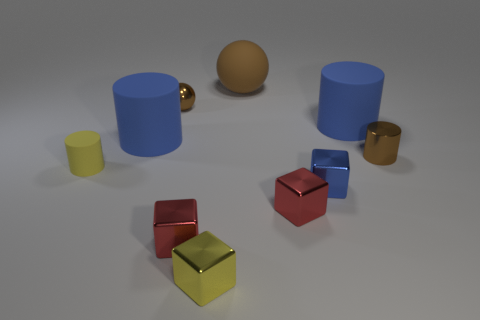Subtract all brown metal cylinders. How many cylinders are left? 3 Subtract all green spheres. How many red blocks are left? 2 Subtract all yellow cylinders. How many cylinders are left? 3 Subtract all cubes. How many objects are left? 6 Subtract all cyan blocks. Subtract all green balls. How many blocks are left? 4 Subtract 1 yellow cylinders. How many objects are left? 9 Subtract all big purple metal balls. Subtract all small red blocks. How many objects are left? 8 Add 7 blue metallic cubes. How many blue metallic cubes are left? 8 Add 9 tiny gray rubber cylinders. How many tiny gray rubber cylinders exist? 9 